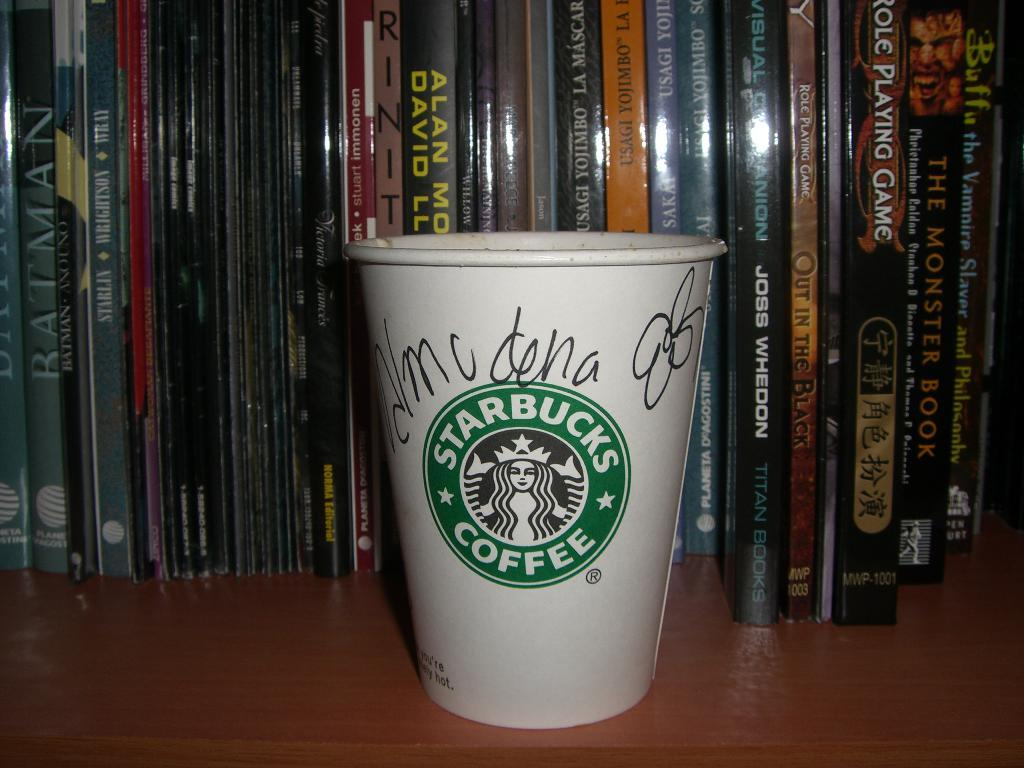<image>
Create a compact narrative representing the image presented. A Starbucks cup has a hand-written name on it. 